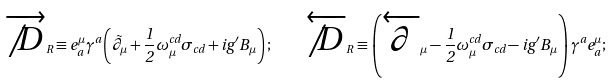<formula> <loc_0><loc_0><loc_500><loc_500>\overrightarrow { \not \, D } _ { R } \equiv e ^ { \mu } _ { a } \gamma ^ { a } \left ( \vec { \partial } _ { \mu } + \frac { 1 } { 2 } \omega _ { \mu } ^ { c d } \sigma _ { c d } + i g ^ { \prime } B _ { \mu } \right ) ; \quad \overleftarrow { \not \, D } _ { R } \equiv \left ( \overleftarrow { \partial } _ { \mu } - \frac { 1 } { 2 } \omega _ { \mu } ^ { c d } \sigma _ { c d } - i g ^ { \prime } B _ { \mu } \right ) \gamma ^ { a } e _ { a } ^ { \mu } ;</formula> 